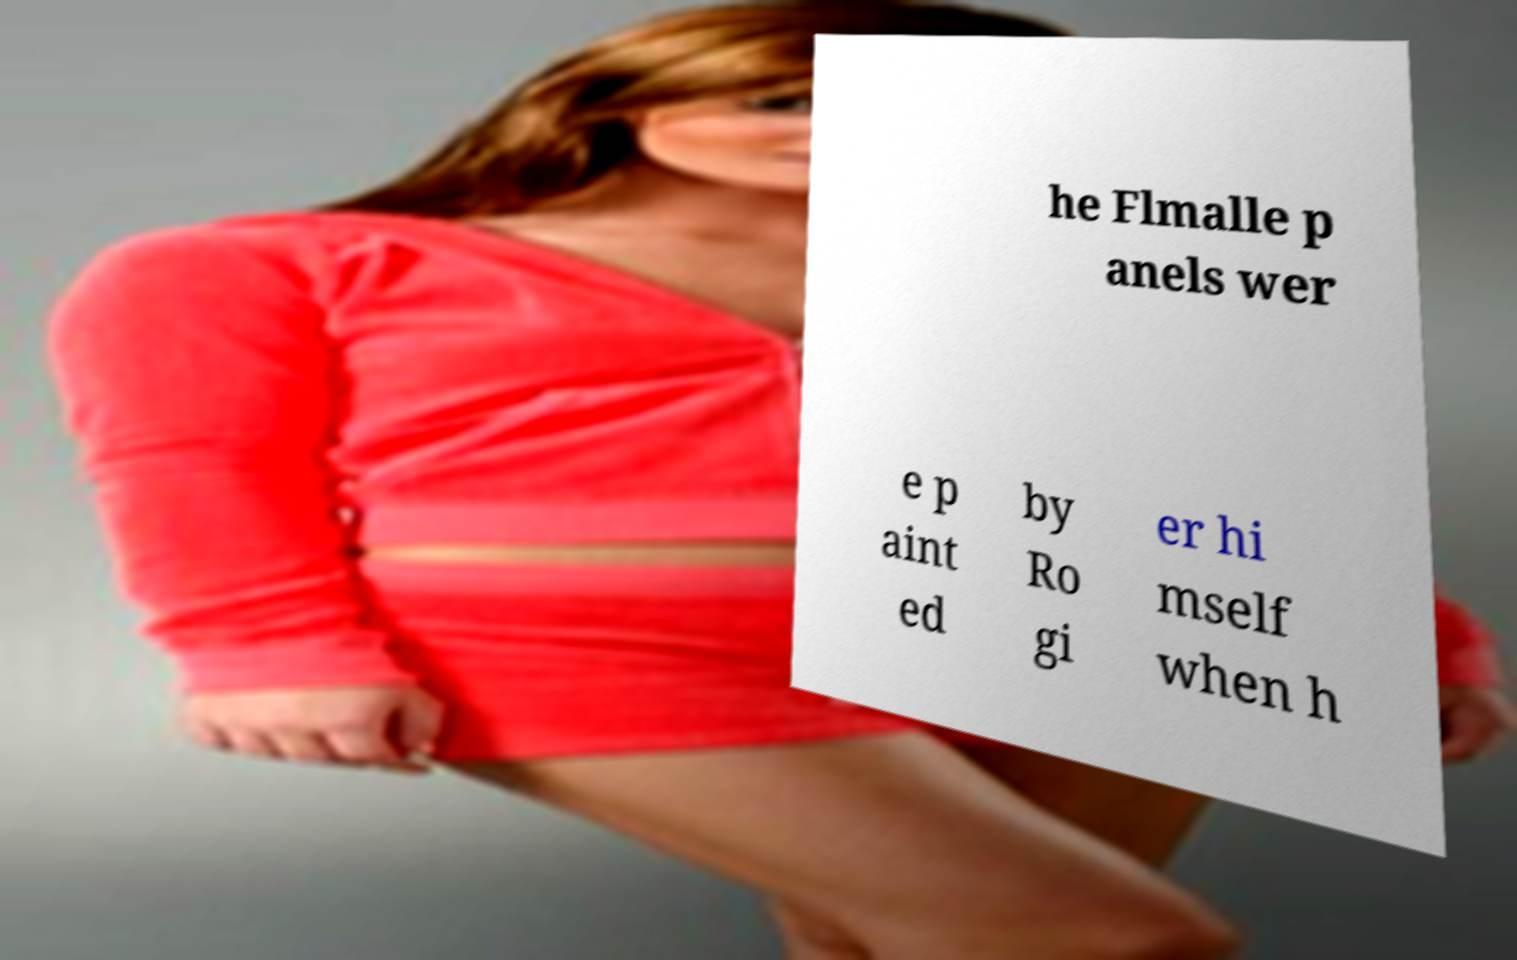Please identify and transcribe the text found in this image. he Flmalle p anels wer e p aint ed by Ro gi er hi mself when h 